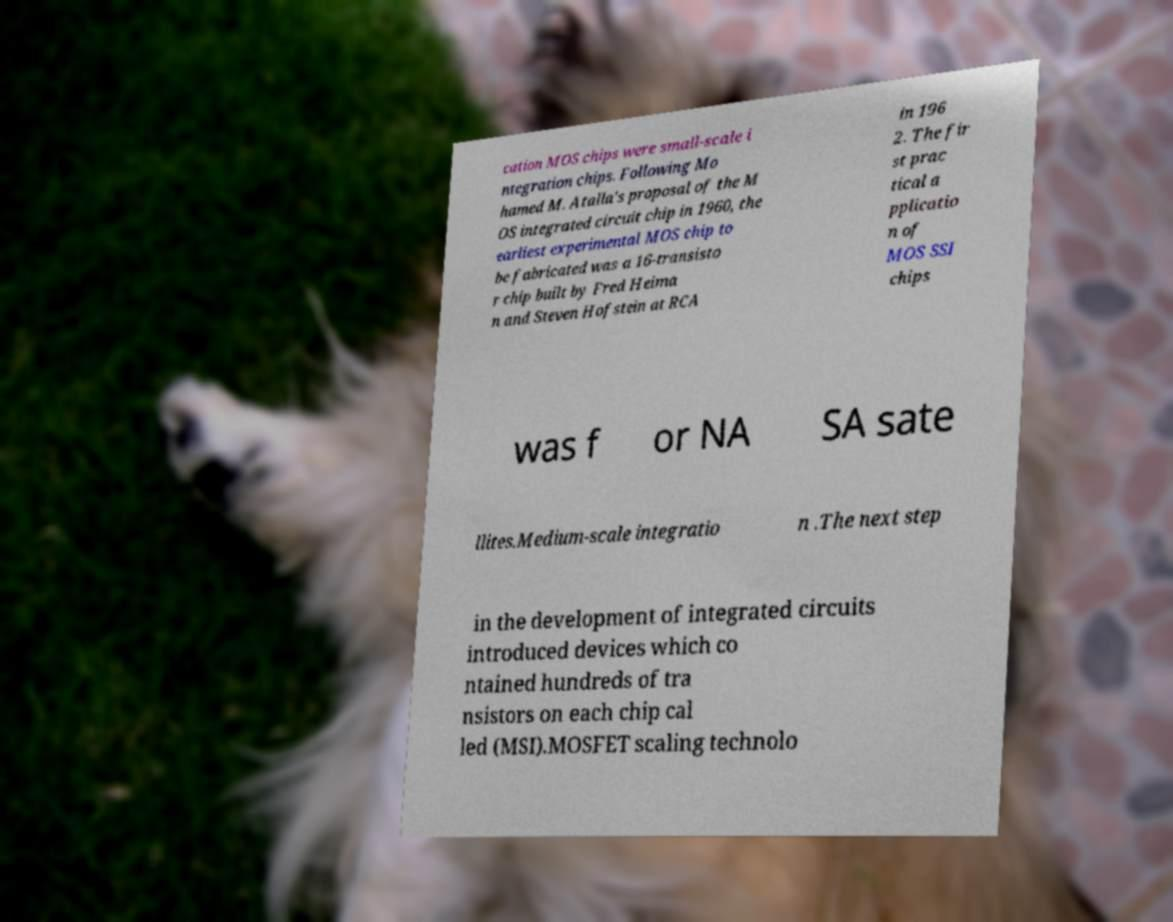Could you assist in decoding the text presented in this image and type it out clearly? cation MOS chips were small-scale i ntegration chips. Following Mo hamed M. Atalla's proposal of the M OS integrated circuit chip in 1960, the earliest experimental MOS chip to be fabricated was a 16-transisto r chip built by Fred Heima n and Steven Hofstein at RCA in 196 2. The fir st prac tical a pplicatio n of MOS SSI chips was f or NA SA sate llites.Medium-scale integratio n .The next step in the development of integrated circuits introduced devices which co ntained hundreds of tra nsistors on each chip cal led (MSI).MOSFET scaling technolo 